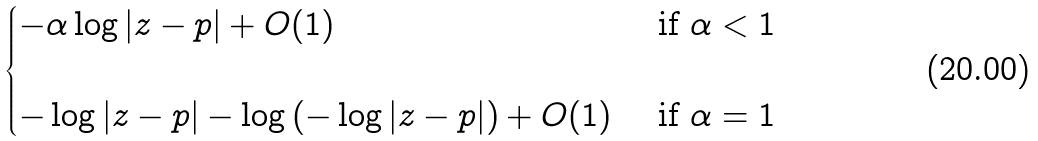<formula> <loc_0><loc_0><loc_500><loc_500>\begin{cases} - \alpha \log | z - p | + O ( 1 ) & \text { if } \alpha < 1 \, \\ \\ - \log | z - p | - \log \left ( - \log | z - p | \right ) + O ( 1 ) & \text { if } \alpha = 1 \, \end{cases}</formula> 